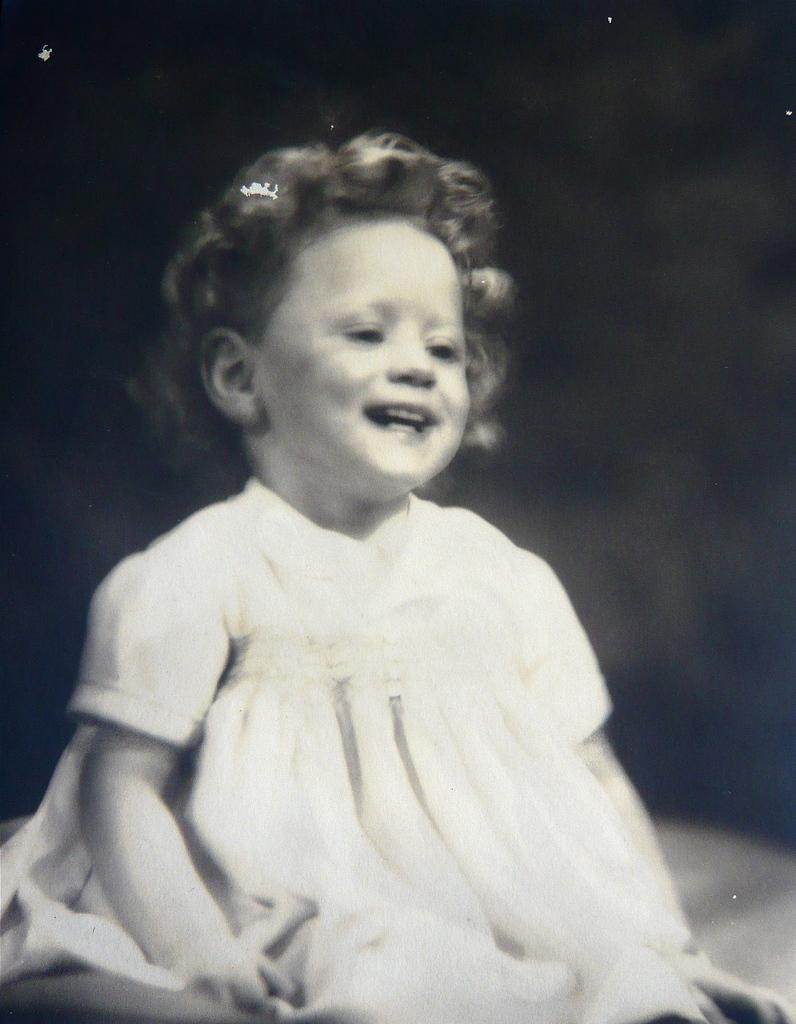What is the color scheme of the image? The image is black and white. What is the main subject of the image? There is a picture of a child in the image. What is the child doing in the image? The child is sitting on a surface. What type of marble is the child playing with in the image? There is no marble present in the image; it is a black and white picture of a child sitting on a surface. What kind of collar is the child wearing in the image? The image is black and white, and there is no detail about the child's clothing, including any collar. 